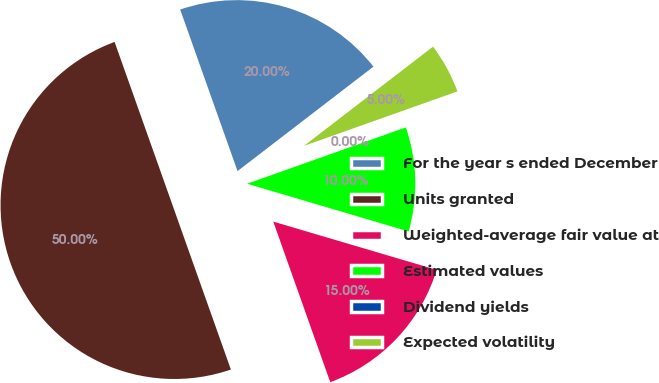<chart> <loc_0><loc_0><loc_500><loc_500><pie_chart><fcel>For the year s ended December<fcel>Units granted<fcel>Weighted-average fair value at<fcel>Estimated values<fcel>Dividend yields<fcel>Expected volatility<nl><fcel>20.0%<fcel>50.0%<fcel>15.0%<fcel>10.0%<fcel>0.0%<fcel>5.0%<nl></chart> 